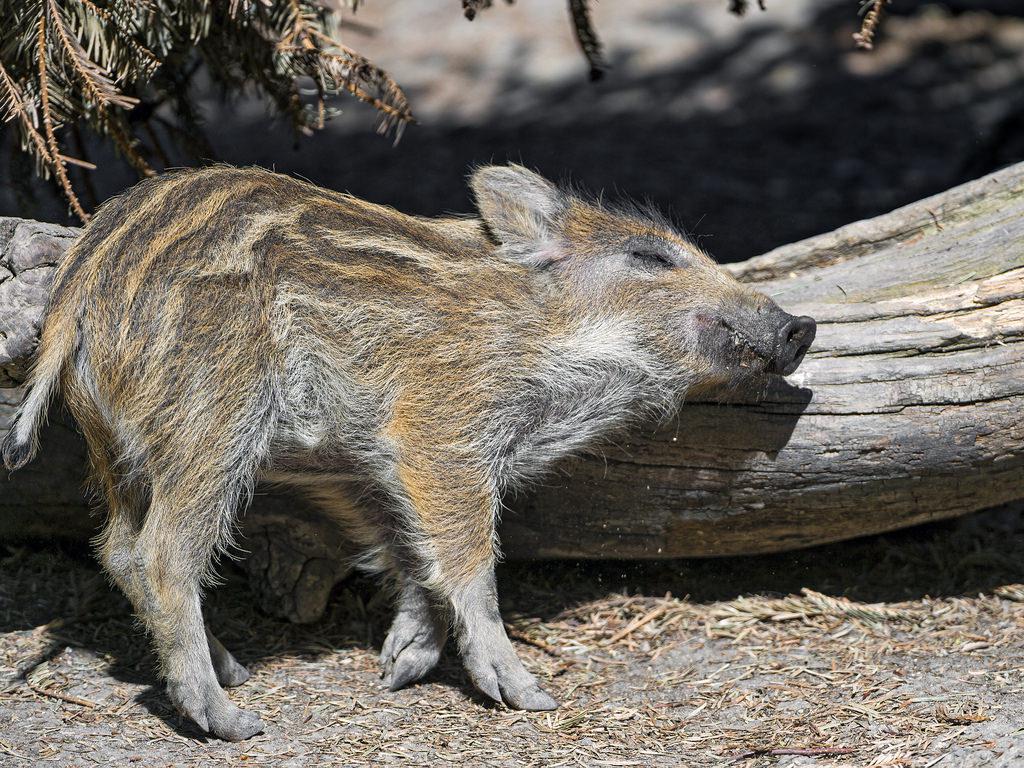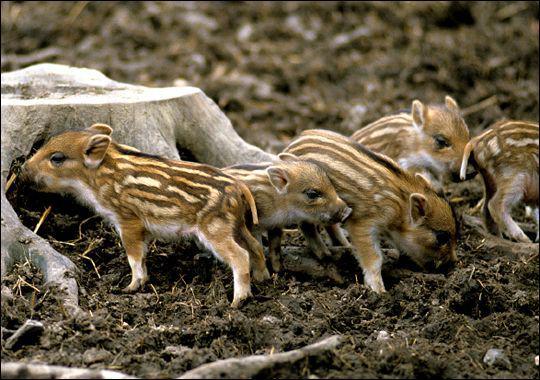The first image is the image on the left, the second image is the image on the right. Given the left and right images, does the statement "There are more pigs in the right image than in the left image." hold true? Answer yes or no. Yes. The first image is the image on the left, the second image is the image on the right. For the images shown, is this caption "There are at most three boar piglets." true? Answer yes or no. No. 